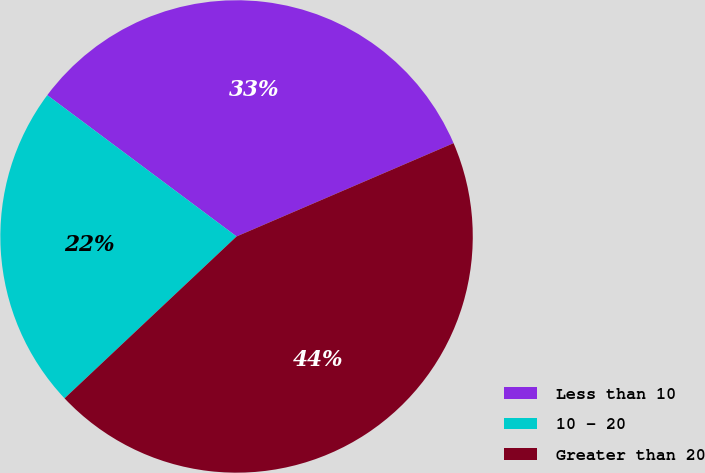Convert chart to OTSL. <chart><loc_0><loc_0><loc_500><loc_500><pie_chart><fcel>Less than 10<fcel>10 - 20<fcel>Greater than 20<nl><fcel>33.33%<fcel>22.22%<fcel>44.44%<nl></chart> 